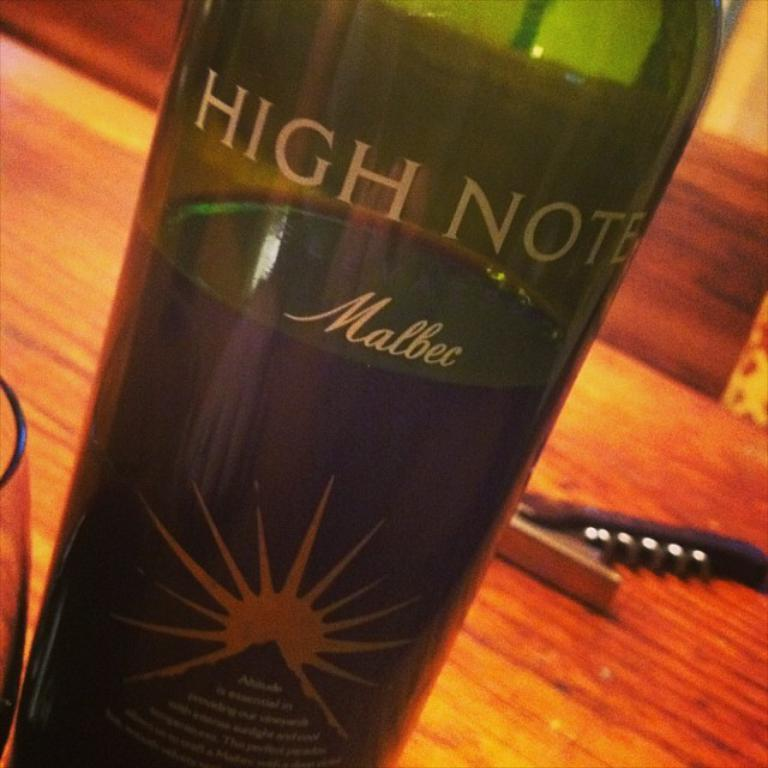<image>
Offer a succinct explanation of the picture presented. A bottle of Malbec has a pyramid and a sun on the label. 